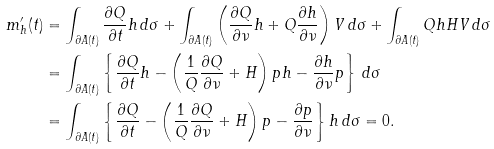Convert formula to latex. <formula><loc_0><loc_0><loc_500><loc_500>m _ { h } ^ { \prime } ( t ) & = \int _ { \partial A ( t ) } \frac { \partial Q } { \partial t } h \, d \sigma + \int _ { \partial A ( t ) } \left ( \frac { \partial Q } { \partial \nu } h + Q \frac { \partial h } { \partial \nu } \right ) V \, d \sigma + \int _ { \partial A ( t ) } Q h H V \, d \sigma \\ & = \int _ { \partial A ( t ) } \left \{ \frac { \partial Q } { \partial t } h - \left ( \frac { 1 } { Q } \frac { \partial Q } { \partial \nu } + H \right ) p h - \frac { \partial h } { \partial \nu } p \right \} \, d \sigma \\ & = \int _ { \partial A ( t ) } \left \{ \frac { \partial Q } { \partial t } - \left ( \frac { 1 } { Q } \frac { \partial Q } { \partial \nu } + H \right ) p - \frac { \partial p } { \partial \nu } \right \} h \, d \sigma = 0 .</formula> 